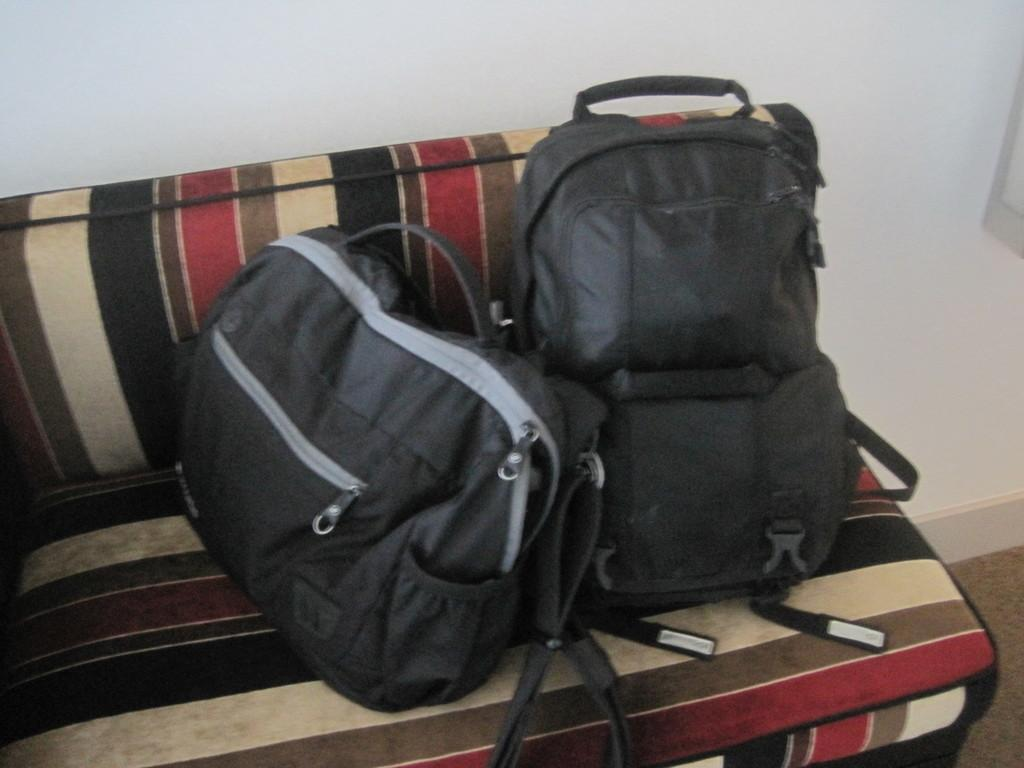What type of furniture is in the image? There is a couch in the image. What colors are used for the couch? The couch is black and red in color. What objects are placed on the couch? There are two bags on the couch. What color are the bags? The bags are black in color. What can be seen behind the couch? There is a wall visible in the image. Are there any plastic flowers on the couch? There are no flowers, plastic or otherwise, present on the couch in the image. 